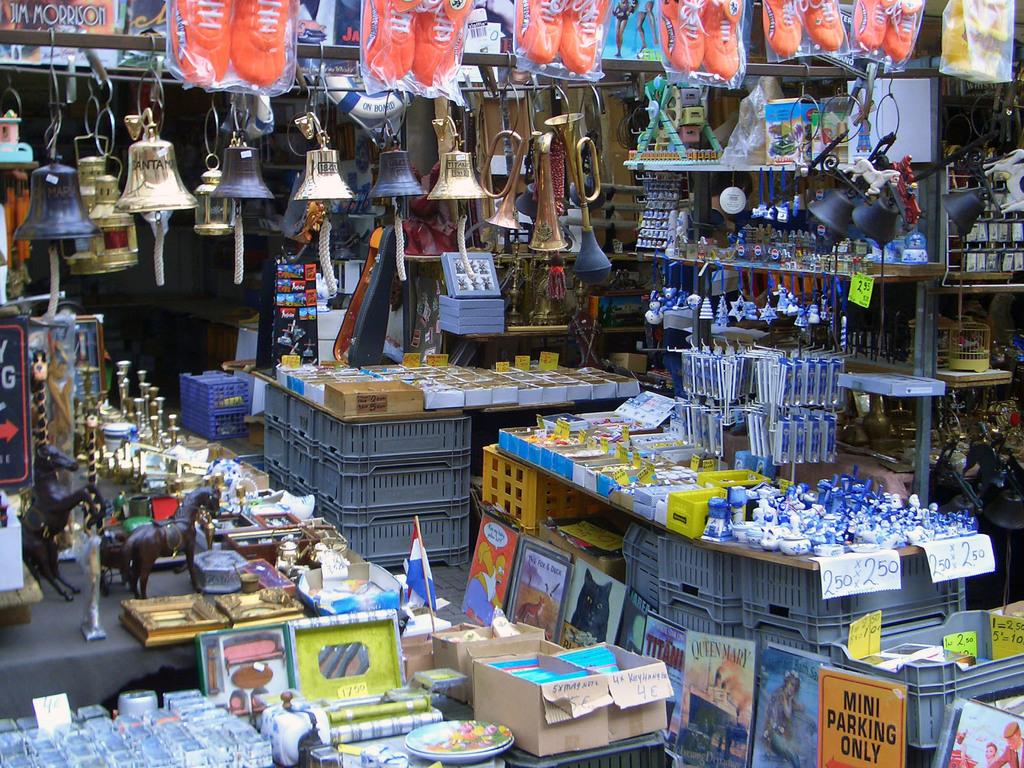Can large cars park here?
Offer a very short reply. No. Are these items on sale?
Give a very brief answer. Yes. 